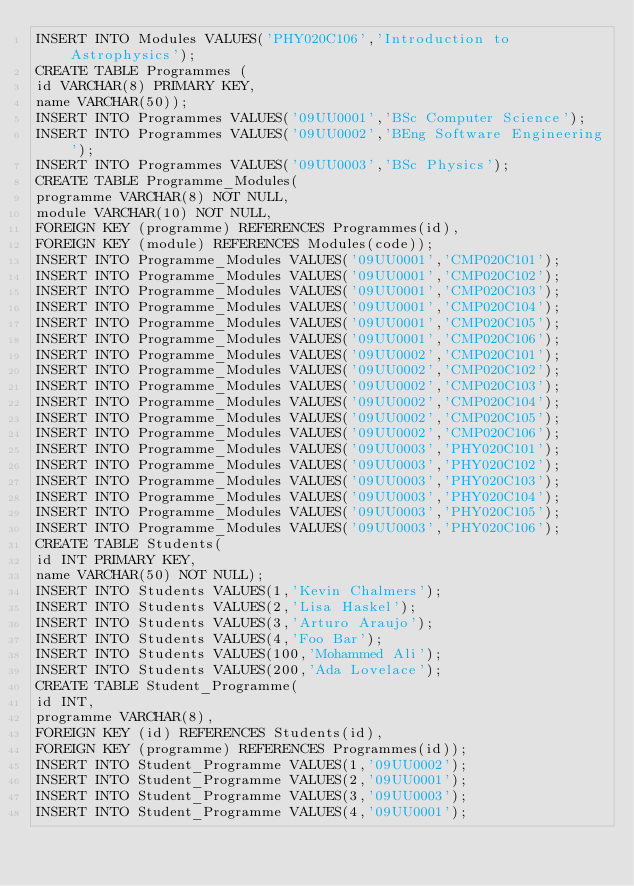Convert code to text. <code><loc_0><loc_0><loc_500><loc_500><_SQL_>INSERT INTO Modules VALUES('PHY020C106','Introduction to Astrophysics');
CREATE TABLE Programmes (
id VARCHAR(8) PRIMARY KEY,
name VARCHAR(50));
INSERT INTO Programmes VALUES('09UU0001','BSc Computer Science');
INSERT INTO Programmes VALUES('09UU0002','BEng Software Engineering');
INSERT INTO Programmes VALUES('09UU0003','BSc Physics');
CREATE TABLE Programme_Modules(
programme VARCHAR(8) NOT NULL,
module VARCHAR(10) NOT NULL,
FOREIGN KEY (programme) REFERENCES Programmes(id),
FOREIGN KEY (module) REFERENCES Modules(code));
INSERT INTO Programme_Modules VALUES('09UU0001','CMP020C101');
INSERT INTO Programme_Modules VALUES('09UU0001','CMP020C102');
INSERT INTO Programme_Modules VALUES('09UU0001','CMP020C103');
INSERT INTO Programme_Modules VALUES('09UU0001','CMP020C104');
INSERT INTO Programme_Modules VALUES('09UU0001','CMP020C105');
INSERT INTO Programme_Modules VALUES('09UU0001','CMP020C106');
INSERT INTO Programme_Modules VALUES('09UU0002','CMP020C101');
INSERT INTO Programme_Modules VALUES('09UU0002','CMP020C102');
INSERT INTO Programme_Modules VALUES('09UU0002','CMP020C103');
INSERT INTO Programme_Modules VALUES('09UU0002','CMP020C104');
INSERT INTO Programme_Modules VALUES('09UU0002','CMP020C105');
INSERT INTO Programme_Modules VALUES('09UU0002','CMP020C106');
INSERT INTO Programme_Modules VALUES('09UU0003','PHY020C101');
INSERT INTO Programme_Modules VALUES('09UU0003','PHY020C102');
INSERT INTO Programme_Modules VALUES('09UU0003','PHY020C103');
INSERT INTO Programme_Modules VALUES('09UU0003','PHY020C104');
INSERT INTO Programme_Modules VALUES('09UU0003','PHY020C105');
INSERT INTO Programme_Modules VALUES('09UU0003','PHY020C106');
CREATE TABLE Students(
id INT PRIMARY KEY,
name VARCHAR(50) NOT NULL);
INSERT INTO Students VALUES(1,'Kevin Chalmers');
INSERT INTO Students VALUES(2,'Lisa Haskel');
INSERT INTO Students VALUES(3,'Arturo Araujo');
INSERT INTO Students VALUES(4,'Foo Bar');
INSERT INTO Students VALUES(100,'Mohammed Ali');
INSERT INTO Students VALUES(200,'Ada Lovelace');
CREATE TABLE Student_Programme(
id INT,
programme VARCHAR(8),
FOREIGN KEY (id) REFERENCES Students(id),
FOREIGN KEY (programme) REFERENCES Programmes(id));
INSERT INTO Student_Programme VALUES(1,'09UU0002');
INSERT INTO Student_Programme VALUES(2,'09UU0001');
INSERT INTO Student_Programme VALUES(3,'09UU0003');
INSERT INTO Student_Programme VALUES(4,'09UU0001');
</code> 